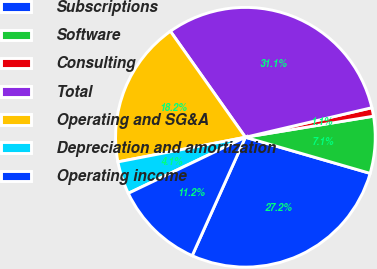Convert chart to OTSL. <chart><loc_0><loc_0><loc_500><loc_500><pie_chart><fcel>Subscriptions<fcel>Software<fcel>Consulting<fcel>Total<fcel>Operating and SG&A<fcel>Depreciation and amortization<fcel>Operating income<nl><fcel>27.24%<fcel>7.08%<fcel>1.06%<fcel>31.15%<fcel>18.24%<fcel>4.07%<fcel>11.17%<nl></chart> 